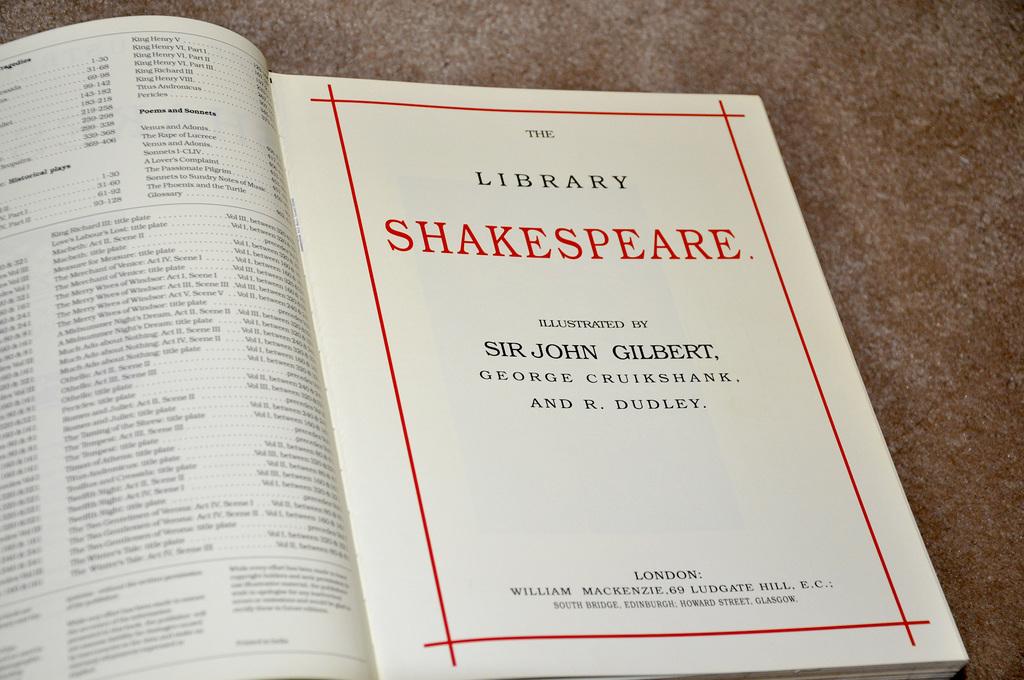Who wrote this book?
Provide a short and direct response. Shakespeare. Who is one of the illustrators of this book?
Keep it short and to the point. Sir john gilbert. 